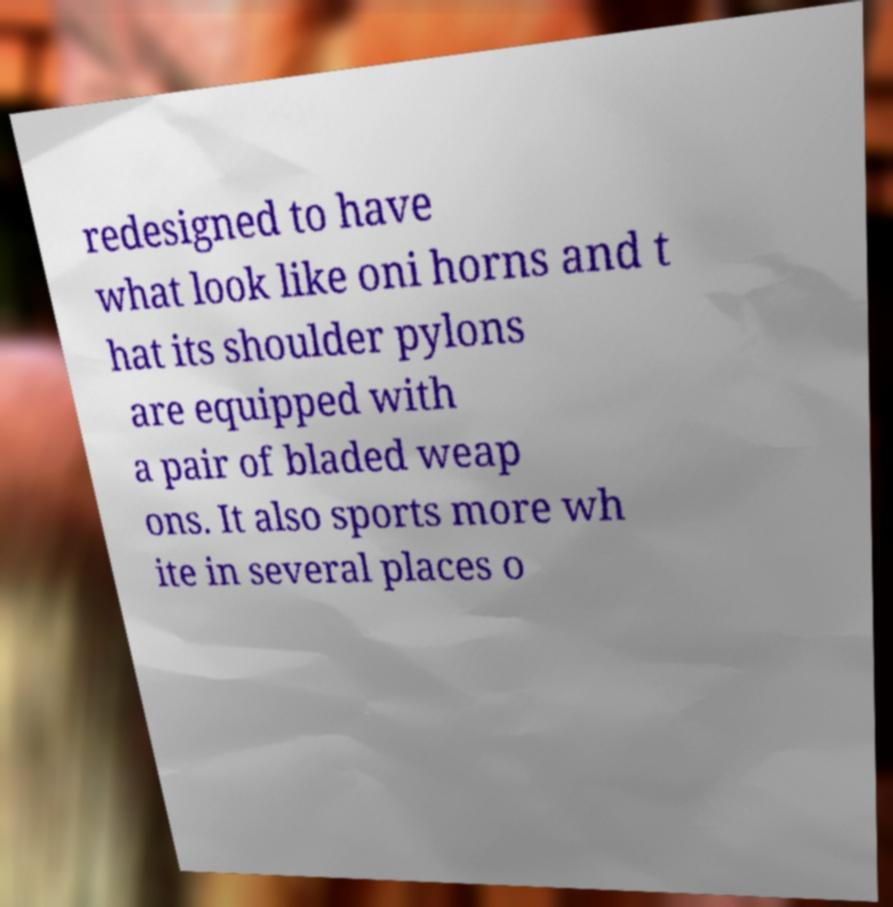Please identify and transcribe the text found in this image. redesigned to have what look like oni horns and t hat its shoulder pylons are equipped with a pair of bladed weap ons. It also sports more wh ite in several places o 